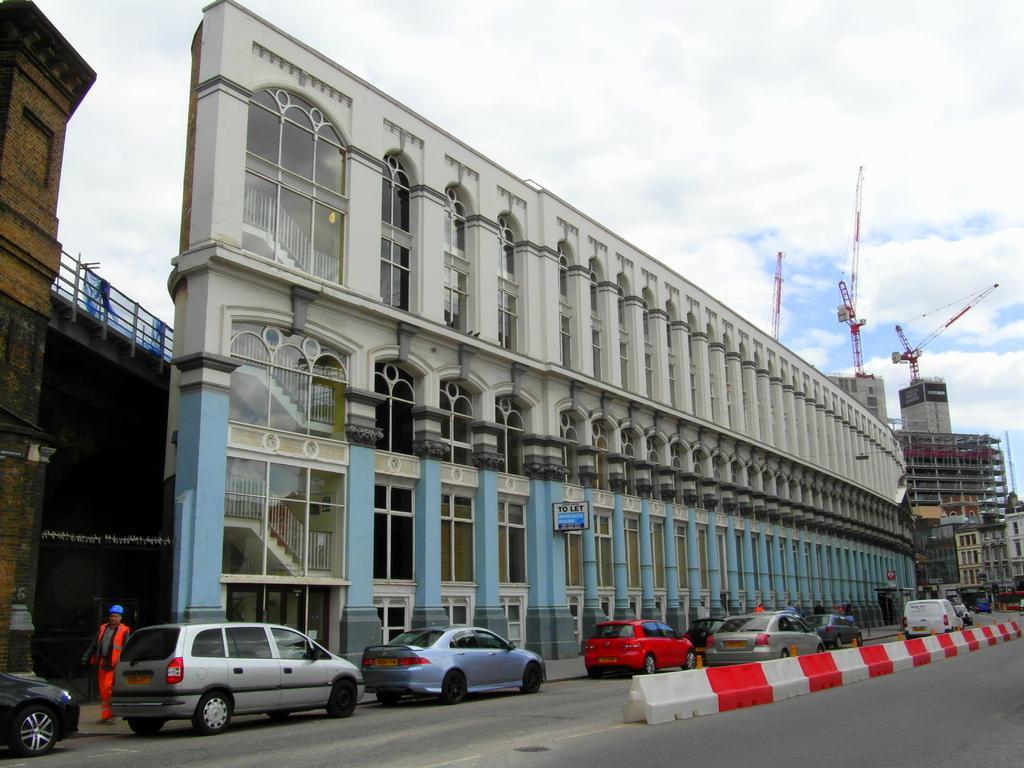Could you give a brief overview of what you see in this image? In this image I can see cars on the road. Few people are standing. There are buildings at the back. There is sky at the top. 